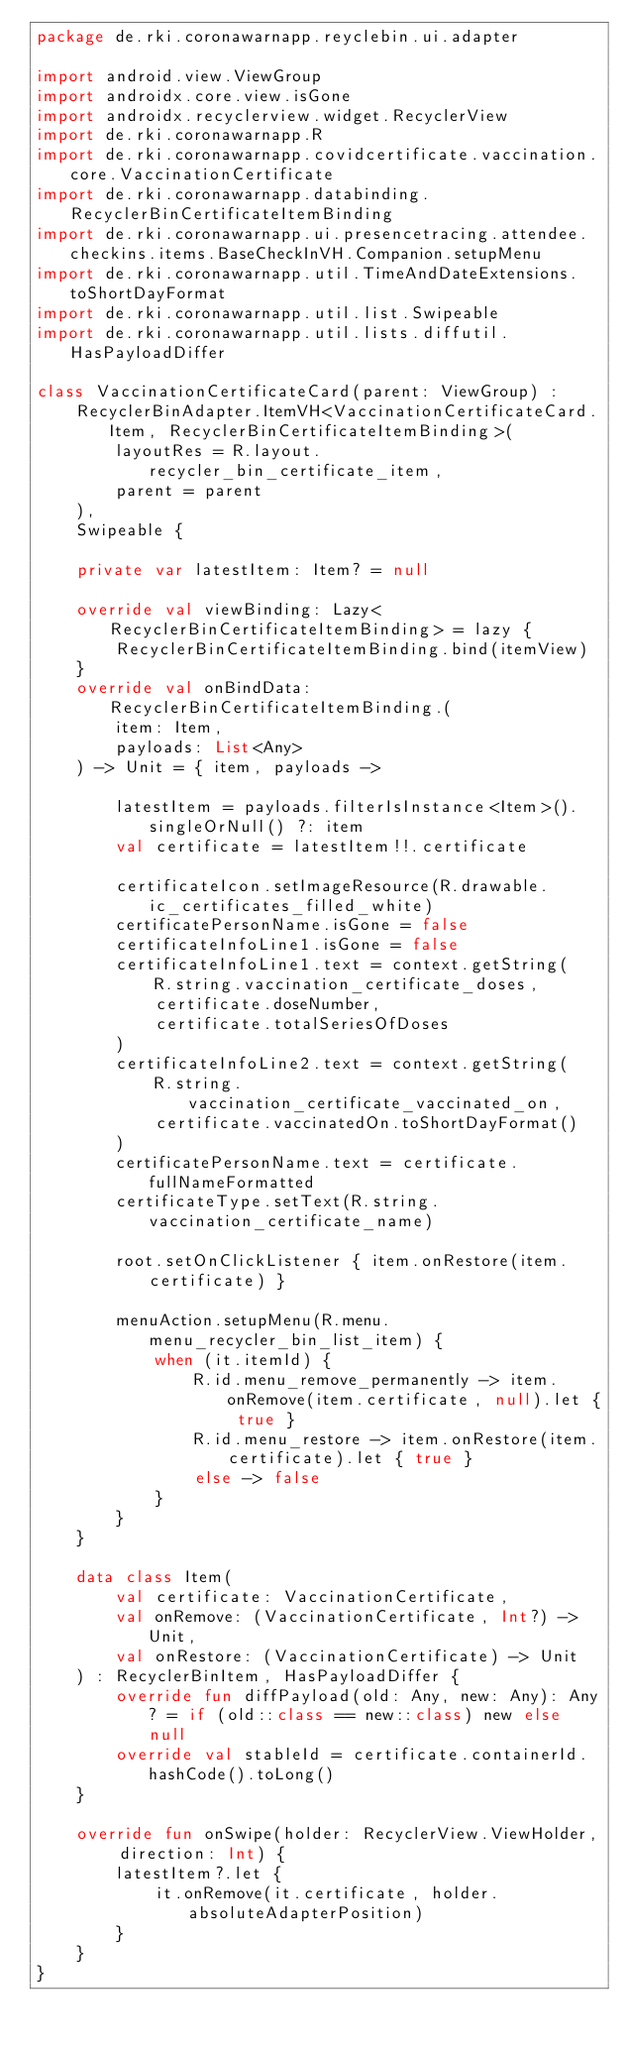Convert code to text. <code><loc_0><loc_0><loc_500><loc_500><_Kotlin_>package de.rki.coronawarnapp.reyclebin.ui.adapter

import android.view.ViewGroup
import androidx.core.view.isGone
import androidx.recyclerview.widget.RecyclerView
import de.rki.coronawarnapp.R
import de.rki.coronawarnapp.covidcertificate.vaccination.core.VaccinationCertificate
import de.rki.coronawarnapp.databinding.RecyclerBinCertificateItemBinding
import de.rki.coronawarnapp.ui.presencetracing.attendee.checkins.items.BaseCheckInVH.Companion.setupMenu
import de.rki.coronawarnapp.util.TimeAndDateExtensions.toShortDayFormat
import de.rki.coronawarnapp.util.list.Swipeable
import de.rki.coronawarnapp.util.lists.diffutil.HasPayloadDiffer

class VaccinationCertificateCard(parent: ViewGroup) :
    RecyclerBinAdapter.ItemVH<VaccinationCertificateCard.Item, RecyclerBinCertificateItemBinding>(
        layoutRes = R.layout.recycler_bin_certificate_item,
        parent = parent
    ),
    Swipeable {

    private var latestItem: Item? = null

    override val viewBinding: Lazy<RecyclerBinCertificateItemBinding> = lazy {
        RecyclerBinCertificateItemBinding.bind(itemView)
    }
    override val onBindData: RecyclerBinCertificateItemBinding.(
        item: Item,
        payloads: List<Any>
    ) -> Unit = { item, payloads ->

        latestItem = payloads.filterIsInstance<Item>().singleOrNull() ?: item
        val certificate = latestItem!!.certificate

        certificateIcon.setImageResource(R.drawable.ic_certificates_filled_white)
        certificatePersonName.isGone = false
        certificateInfoLine1.isGone = false
        certificateInfoLine1.text = context.getString(
            R.string.vaccination_certificate_doses,
            certificate.doseNumber,
            certificate.totalSeriesOfDoses
        )
        certificateInfoLine2.text = context.getString(
            R.string.vaccination_certificate_vaccinated_on,
            certificate.vaccinatedOn.toShortDayFormat()
        )
        certificatePersonName.text = certificate.fullNameFormatted
        certificateType.setText(R.string.vaccination_certificate_name)

        root.setOnClickListener { item.onRestore(item.certificate) }

        menuAction.setupMenu(R.menu.menu_recycler_bin_list_item) {
            when (it.itemId) {
                R.id.menu_remove_permanently -> item.onRemove(item.certificate, null).let { true }
                R.id.menu_restore -> item.onRestore(item.certificate).let { true }
                else -> false
            }
        }
    }

    data class Item(
        val certificate: VaccinationCertificate,
        val onRemove: (VaccinationCertificate, Int?) -> Unit,
        val onRestore: (VaccinationCertificate) -> Unit
    ) : RecyclerBinItem, HasPayloadDiffer {
        override fun diffPayload(old: Any, new: Any): Any? = if (old::class == new::class) new else null
        override val stableId = certificate.containerId.hashCode().toLong()
    }

    override fun onSwipe(holder: RecyclerView.ViewHolder, direction: Int) {
        latestItem?.let {
            it.onRemove(it.certificate, holder.absoluteAdapterPosition)
        }
    }
}
</code> 